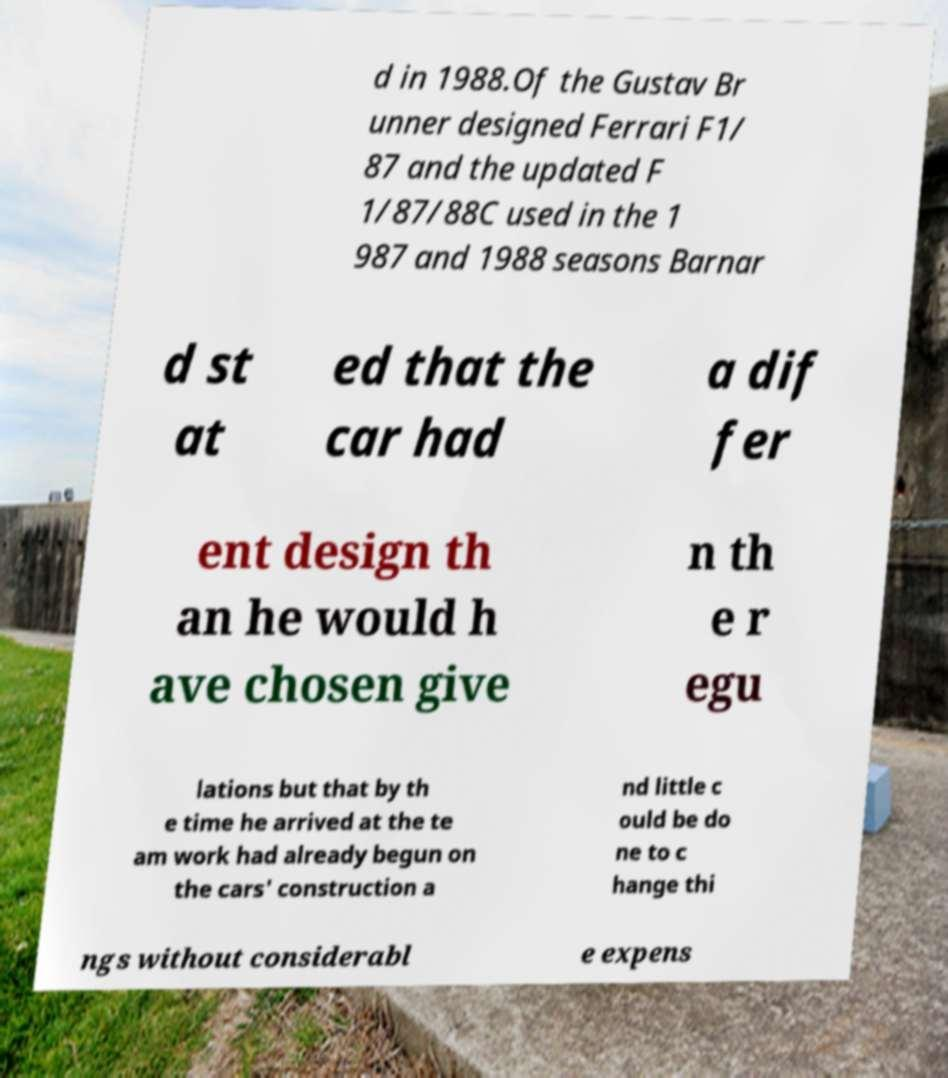Could you assist in decoding the text presented in this image and type it out clearly? d in 1988.Of the Gustav Br unner designed Ferrari F1/ 87 and the updated F 1/87/88C used in the 1 987 and 1988 seasons Barnar d st at ed that the car had a dif fer ent design th an he would h ave chosen give n th e r egu lations but that by th e time he arrived at the te am work had already begun on the cars' construction a nd little c ould be do ne to c hange thi ngs without considerabl e expens 